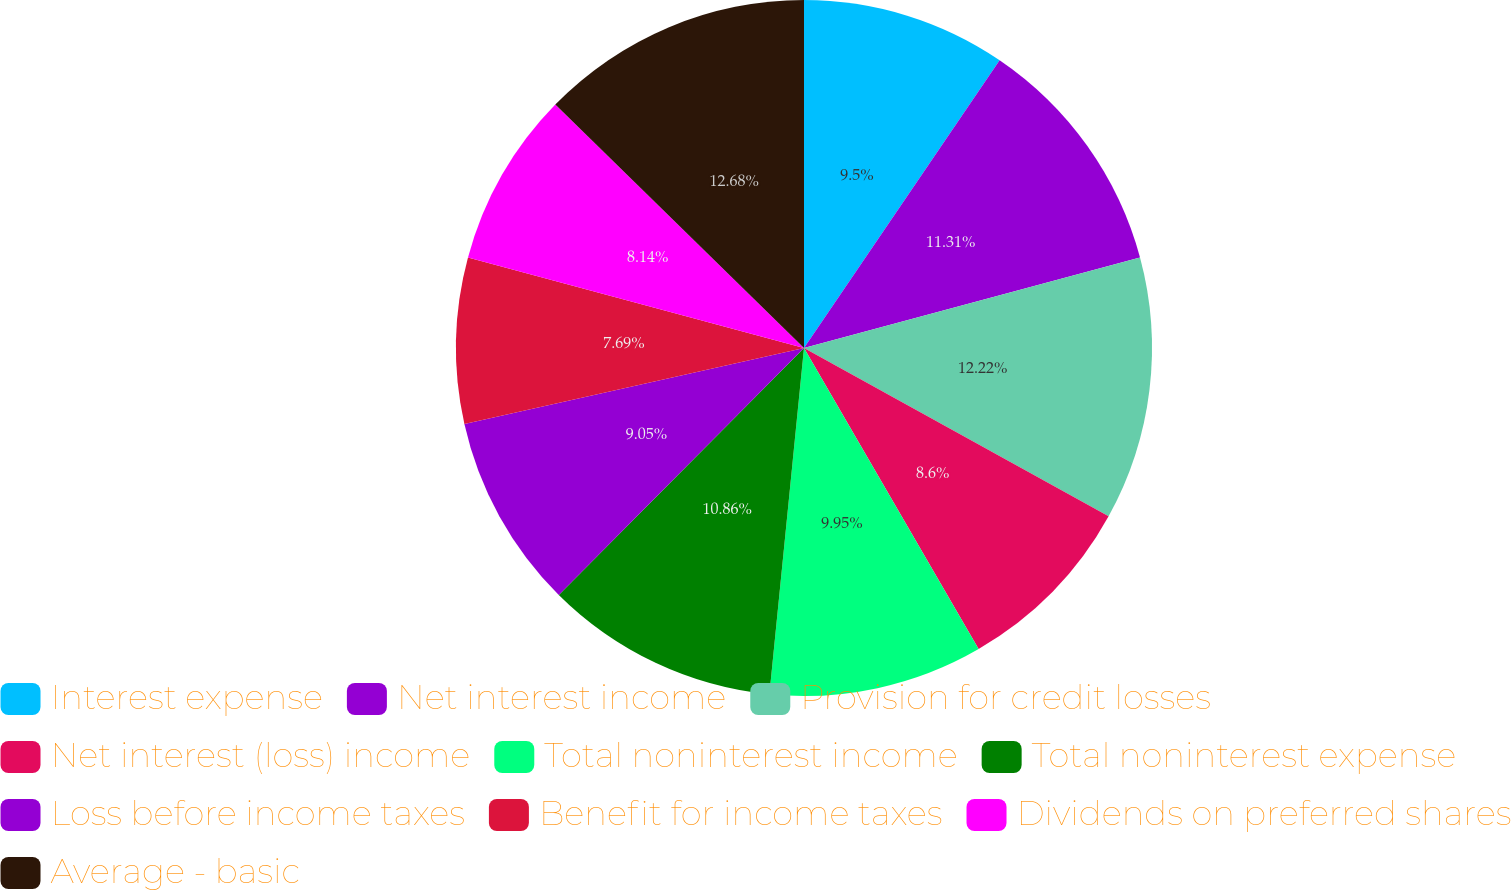Convert chart to OTSL. <chart><loc_0><loc_0><loc_500><loc_500><pie_chart><fcel>Interest expense<fcel>Net interest income<fcel>Provision for credit losses<fcel>Net interest (loss) income<fcel>Total noninterest income<fcel>Total noninterest expense<fcel>Loss before income taxes<fcel>Benefit for income taxes<fcel>Dividends on preferred shares<fcel>Average - basic<nl><fcel>9.5%<fcel>11.31%<fcel>12.22%<fcel>8.6%<fcel>9.95%<fcel>10.86%<fcel>9.05%<fcel>7.69%<fcel>8.14%<fcel>12.67%<nl></chart> 